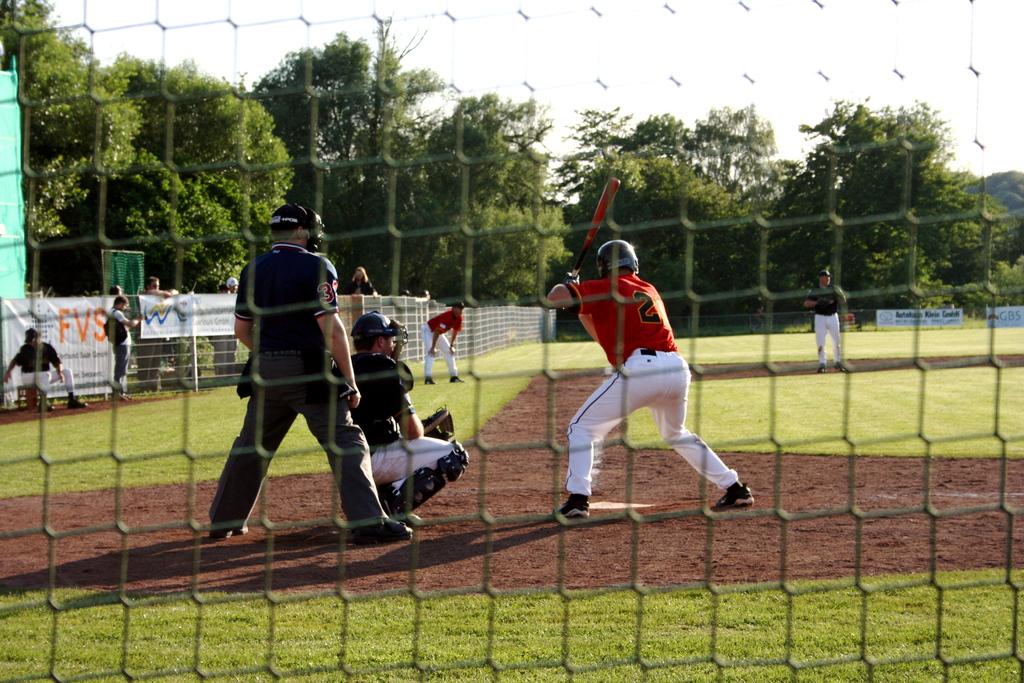What jersey number is shown on the batter?
Make the answer very short. 2. Is this batter left handed?
Offer a very short reply. Yes. 